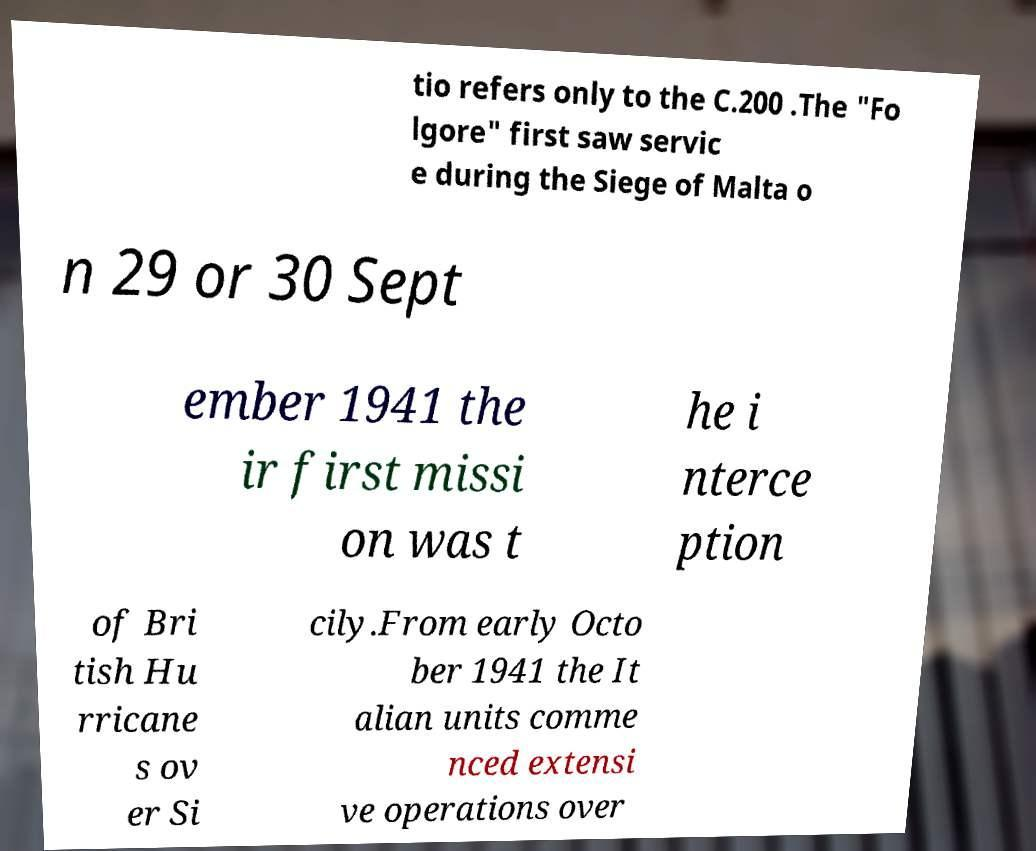Please identify and transcribe the text found in this image. tio refers only to the C.200 .The "Fo lgore" first saw servic e during the Siege of Malta o n 29 or 30 Sept ember 1941 the ir first missi on was t he i nterce ption of Bri tish Hu rricane s ov er Si cily.From early Octo ber 1941 the It alian units comme nced extensi ve operations over 